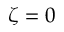<formula> <loc_0><loc_0><loc_500><loc_500>\zeta = 0</formula> 